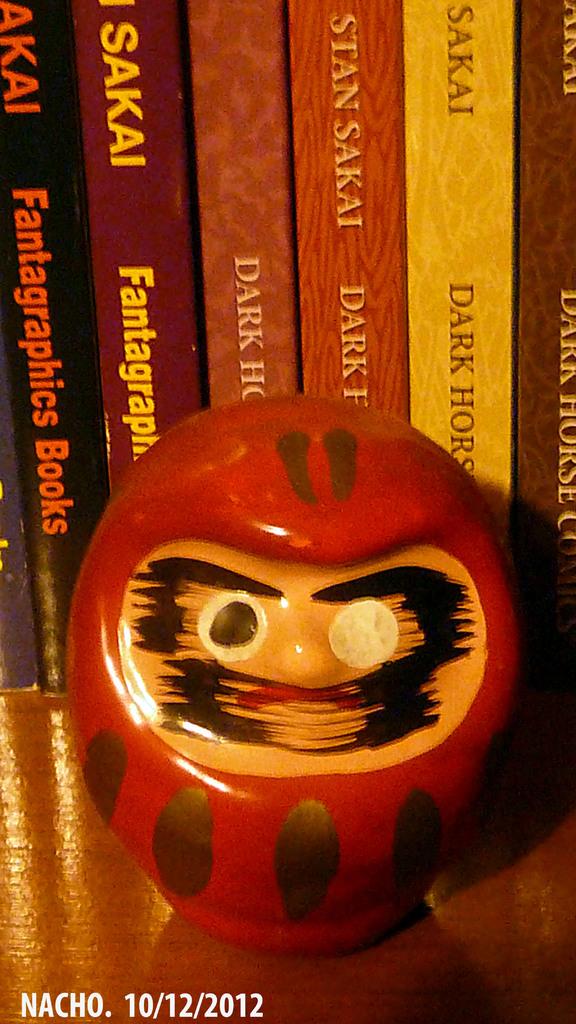What is the title of the orange and black book?
Your answer should be very brief. Fantagraphics books. What is the date of the picture?
Keep it short and to the point. 10/12/2012. 